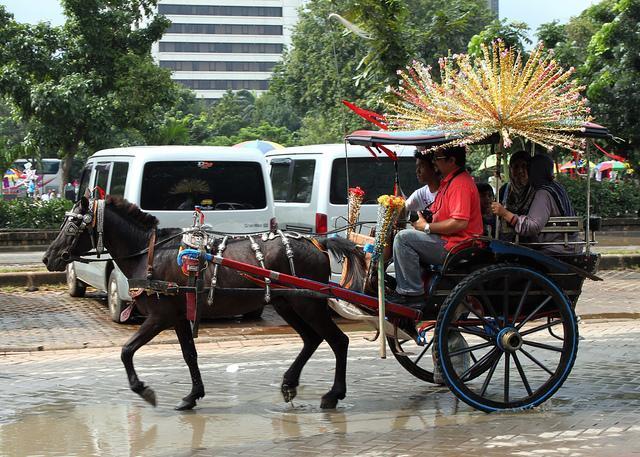How many white socks does the horse have?
Give a very brief answer. 0. How many people are in the picture?
Give a very brief answer. 2. How many trucks are in the photo?
Give a very brief answer. 2. How many cars are in the photo?
Give a very brief answer. 2. How many red frisbees are airborne?
Give a very brief answer. 0. 